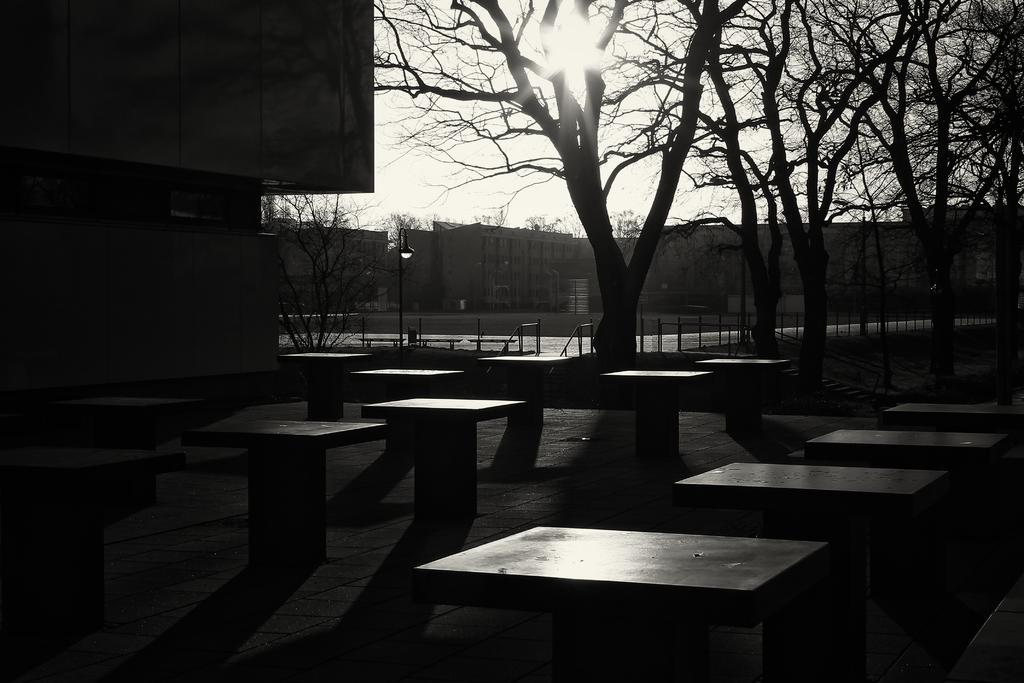What is the color scheme of the image? The image is black and white. What can be seen on the ground at the bottom of the image? There are platforms on the ground at the bottom of the image. What is visible in the background of the image? Trees, buildings, light poles, fences, the sun, and the sky are visible in the background of the image. What type of polish is being applied to the trees in the image? There is no indication in the image that any polish is being applied to the trees. What is the cause of the loss experienced by the buildings in the image? There is no indication in the image of any loss experienced by the buildings. 